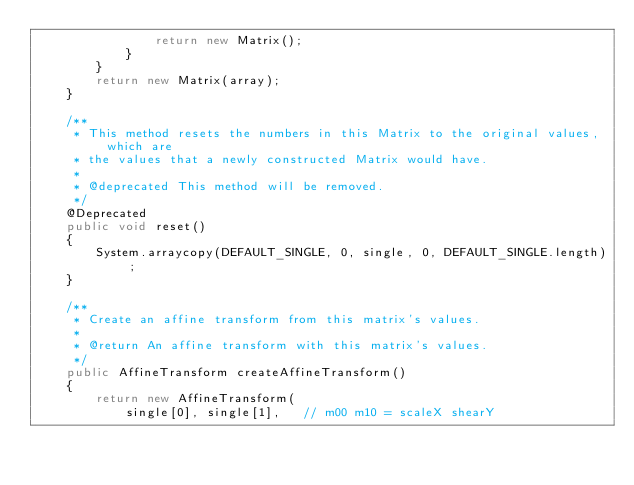<code> <loc_0><loc_0><loc_500><loc_500><_Java_>                return new Matrix();
            }
        }
        return new Matrix(array);
    }

    /**
     * This method resets the numbers in this Matrix to the original values, which are
     * the values that a newly constructed Matrix would have.
     *
     * @deprecated This method will be removed.
     */
    @Deprecated
    public void reset()
    {
        System.arraycopy(DEFAULT_SINGLE, 0, single, 0, DEFAULT_SINGLE.length);
    }

    /**
     * Create an affine transform from this matrix's values.
     *
     * @return An affine transform with this matrix's values.
     */
    public AffineTransform createAffineTransform()
    {
        return new AffineTransform(
            single[0], single[1],   // m00 m10 = scaleX shearY</code> 